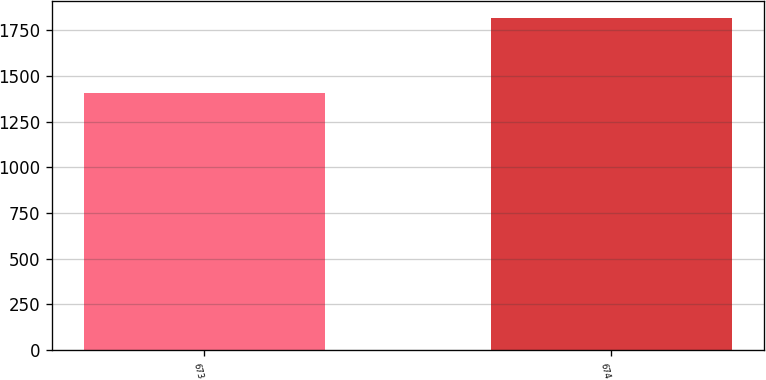<chart> <loc_0><loc_0><loc_500><loc_500><bar_chart><fcel>673<fcel>674<nl><fcel>1404.4<fcel>1819<nl></chart> 